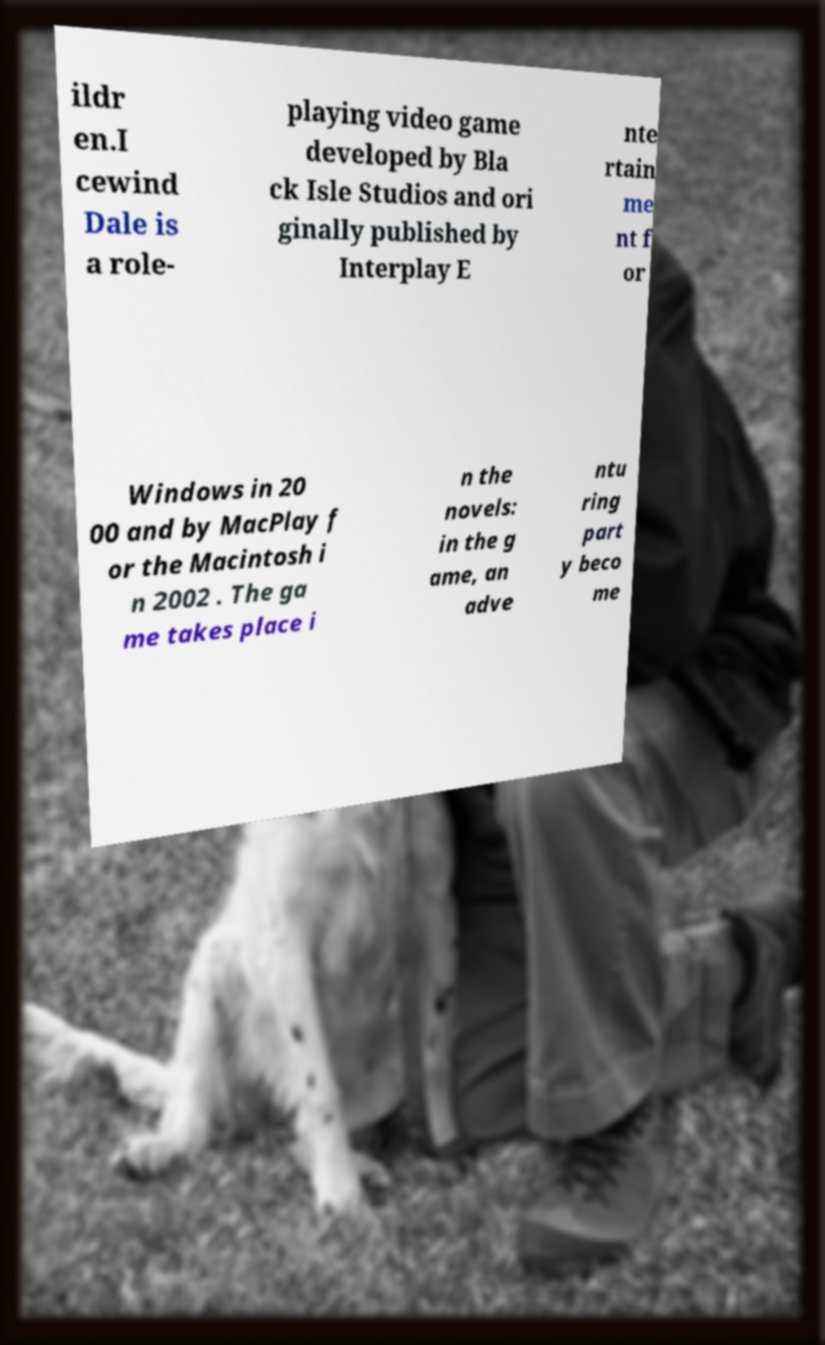Can you read and provide the text displayed in the image?This photo seems to have some interesting text. Can you extract and type it out for me? ildr en.I cewind Dale is a role- playing video game developed by Bla ck Isle Studios and ori ginally published by Interplay E nte rtain me nt f or Windows in 20 00 and by MacPlay f or the Macintosh i n 2002 . The ga me takes place i n the novels: in the g ame, an adve ntu ring part y beco me 